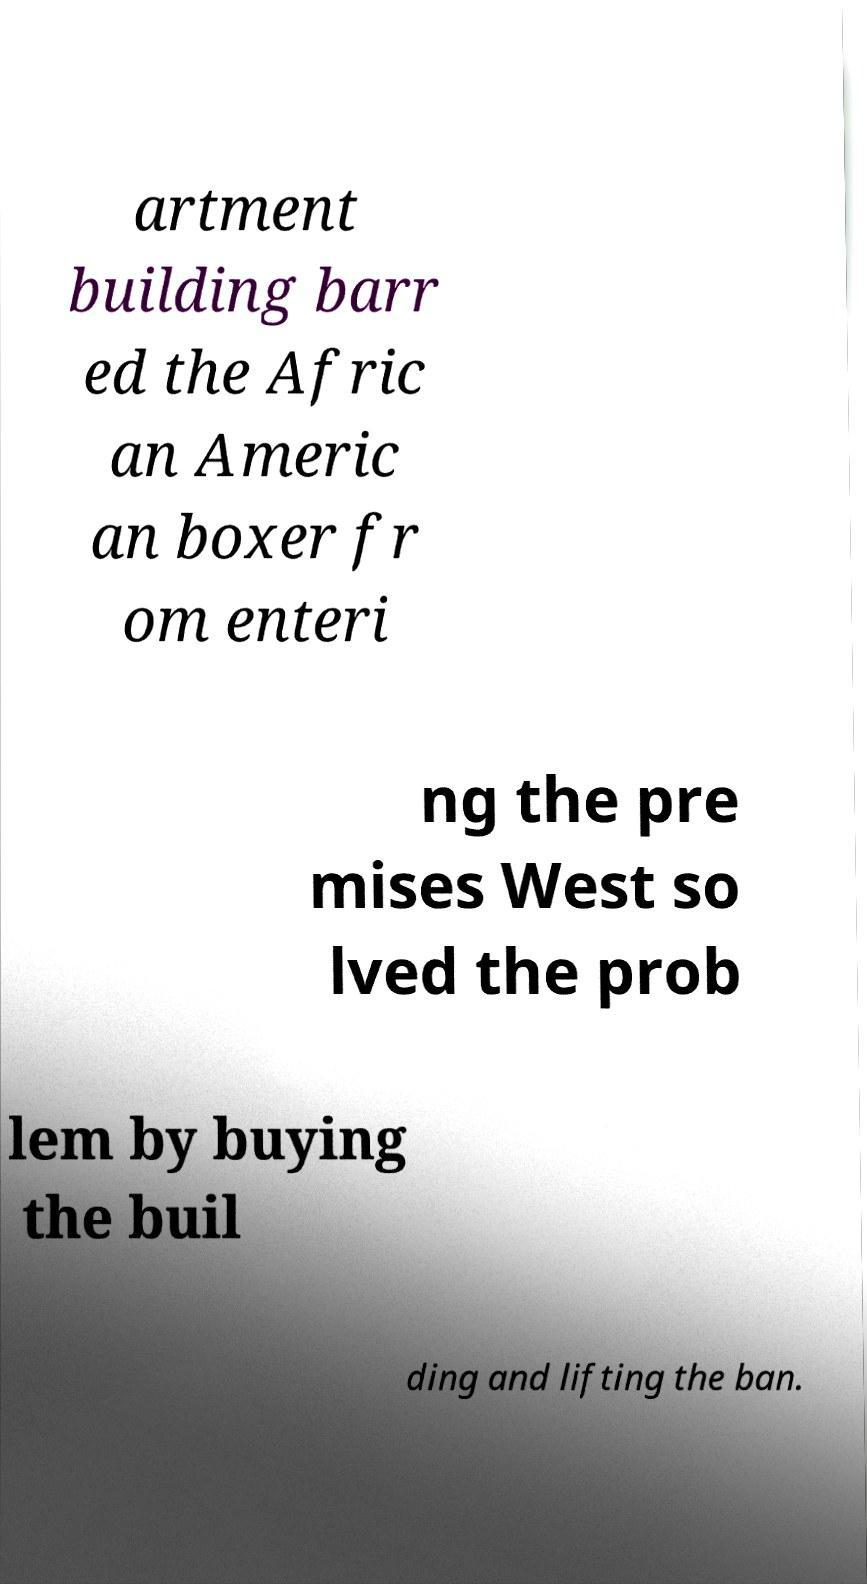Can you accurately transcribe the text from the provided image for me? artment building barr ed the Afric an Americ an boxer fr om enteri ng the pre mises West so lved the prob lem by buying the buil ding and lifting the ban. 